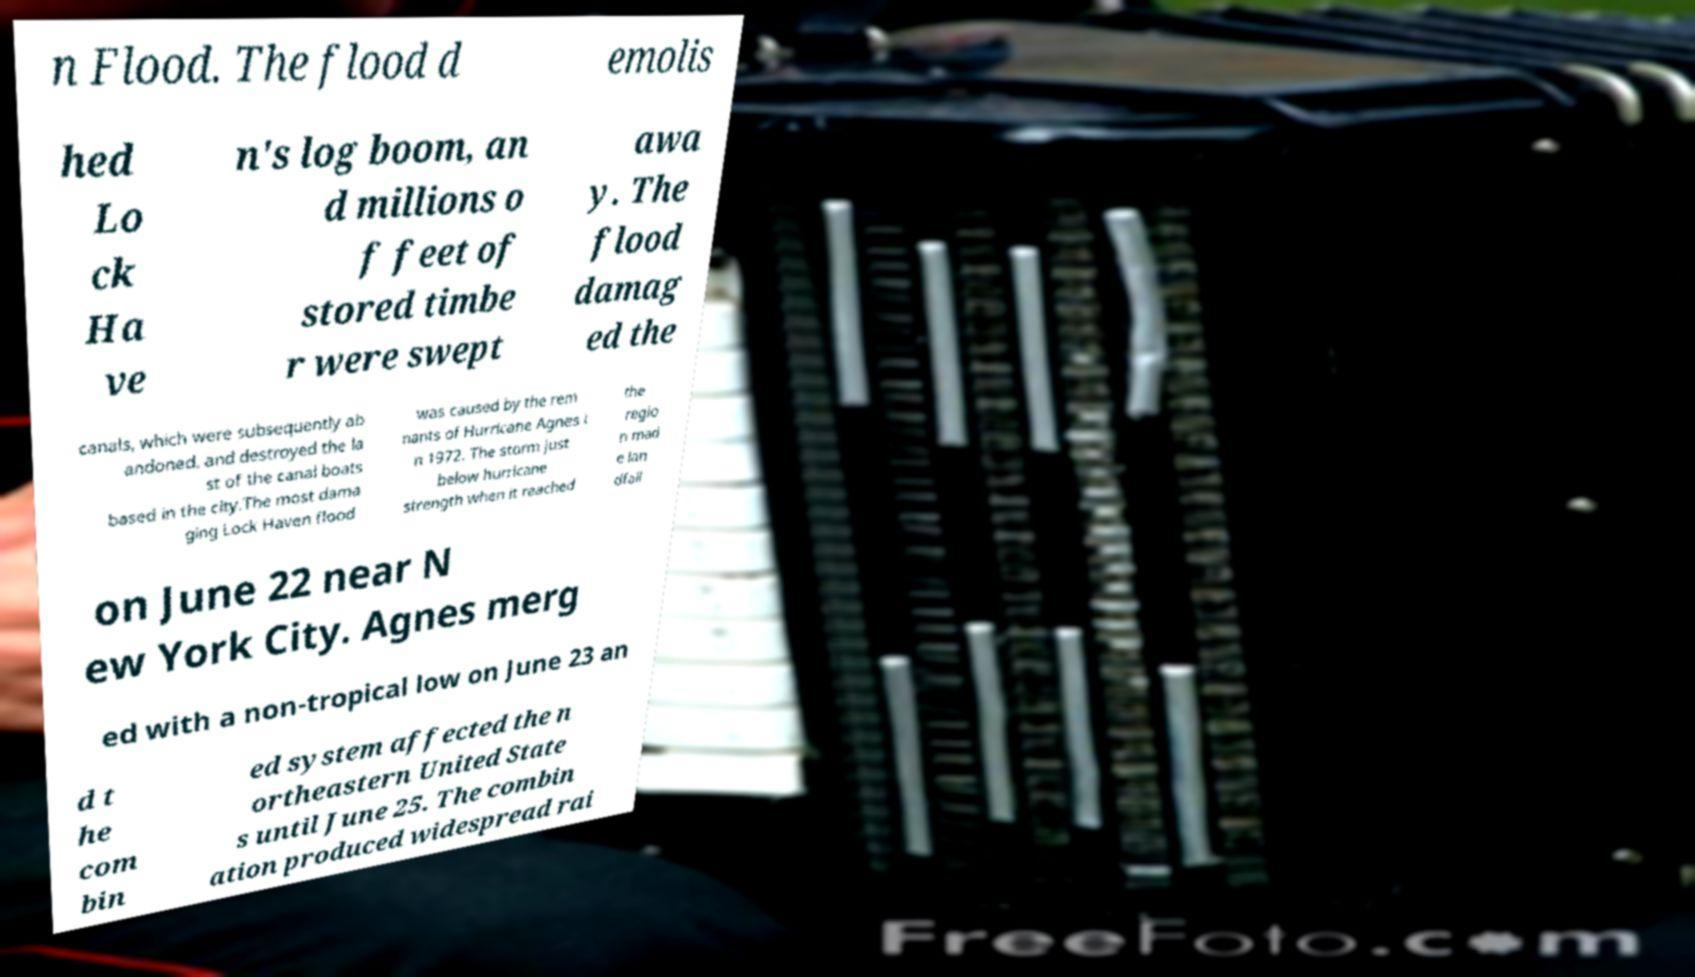There's text embedded in this image that I need extracted. Can you transcribe it verbatim? n Flood. The flood d emolis hed Lo ck Ha ve n's log boom, an d millions o f feet of stored timbe r were swept awa y. The flood damag ed the canals, which were subsequently ab andoned, and destroyed the la st of the canal boats based in the city.The most dama ging Lock Haven flood was caused by the rem nants of Hurricane Agnes i n 1972. The storm just below hurricane strength when it reached the regio n mad e lan dfall on June 22 near N ew York City. Agnes merg ed with a non-tropical low on June 23 an d t he com bin ed system affected the n ortheastern United State s until June 25. The combin ation produced widespread rai 